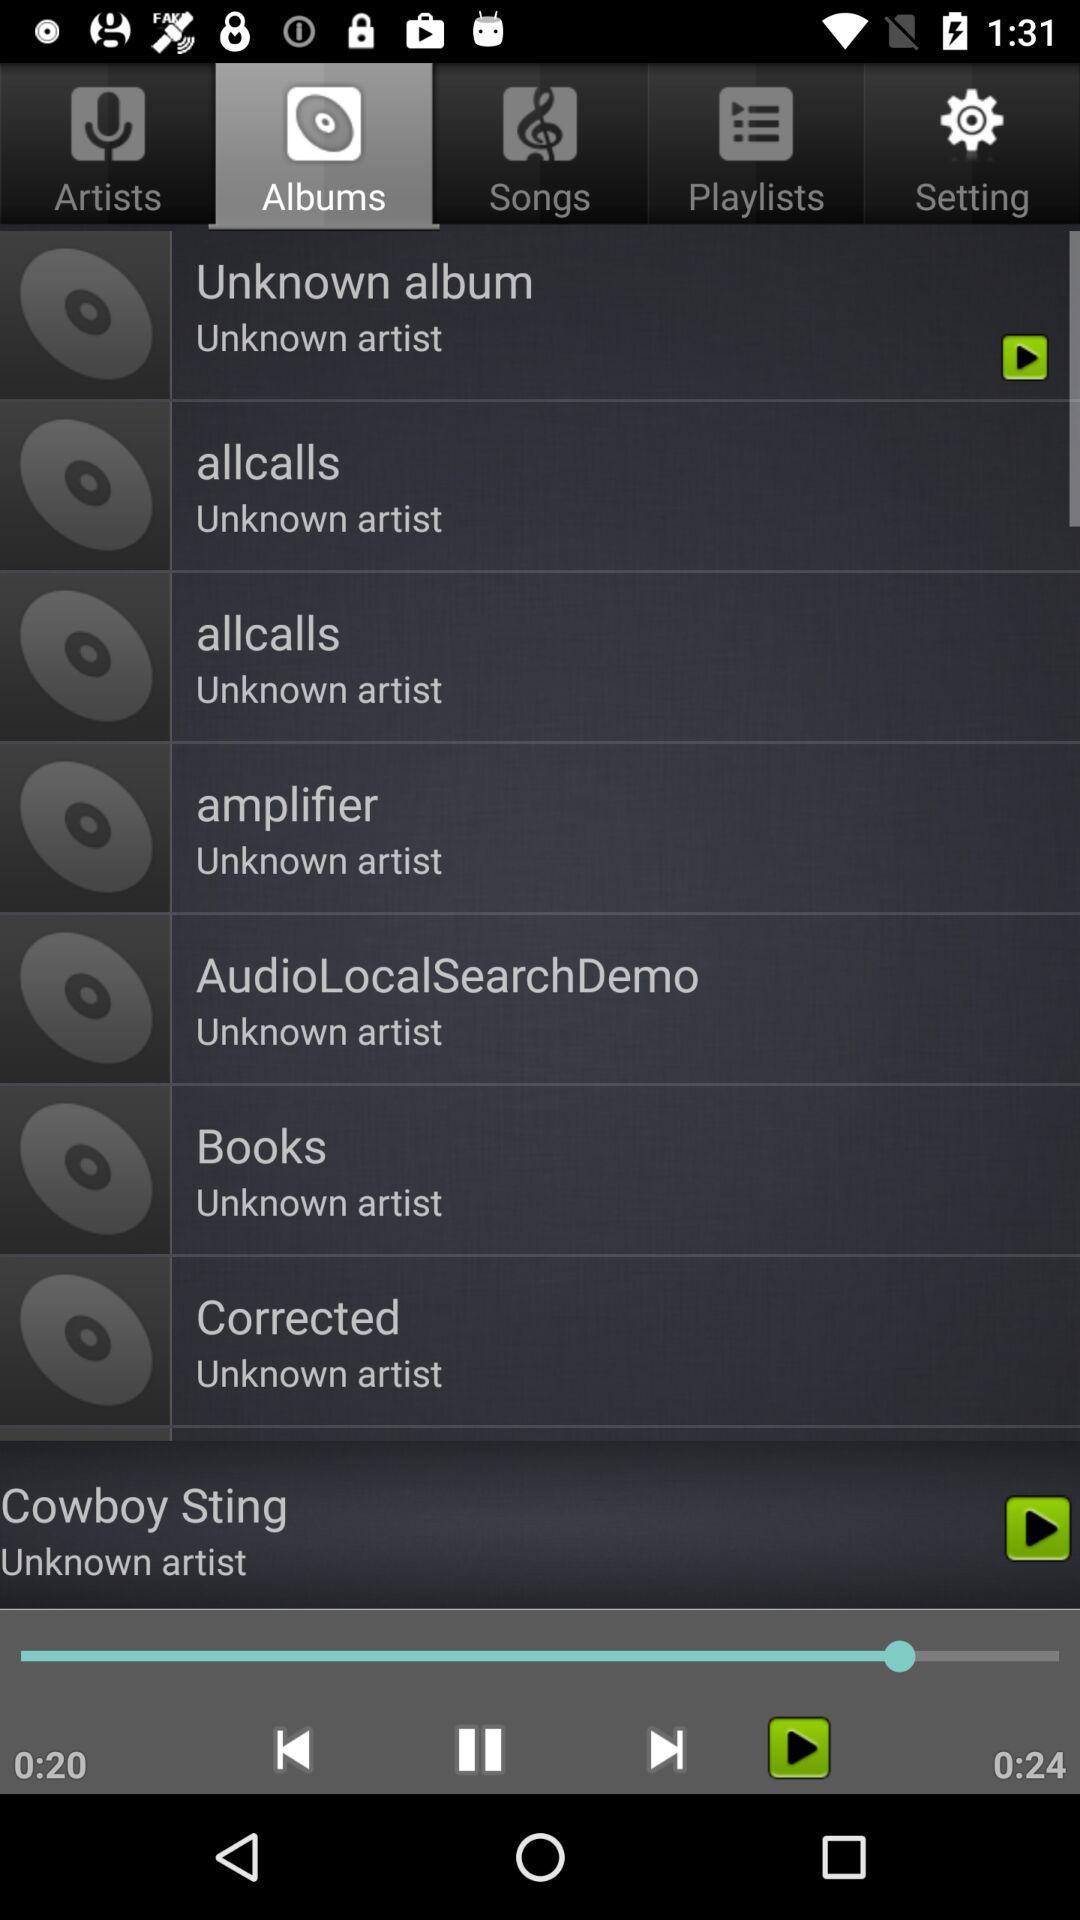Which tab am I on? You are on the "Albums" tab. 